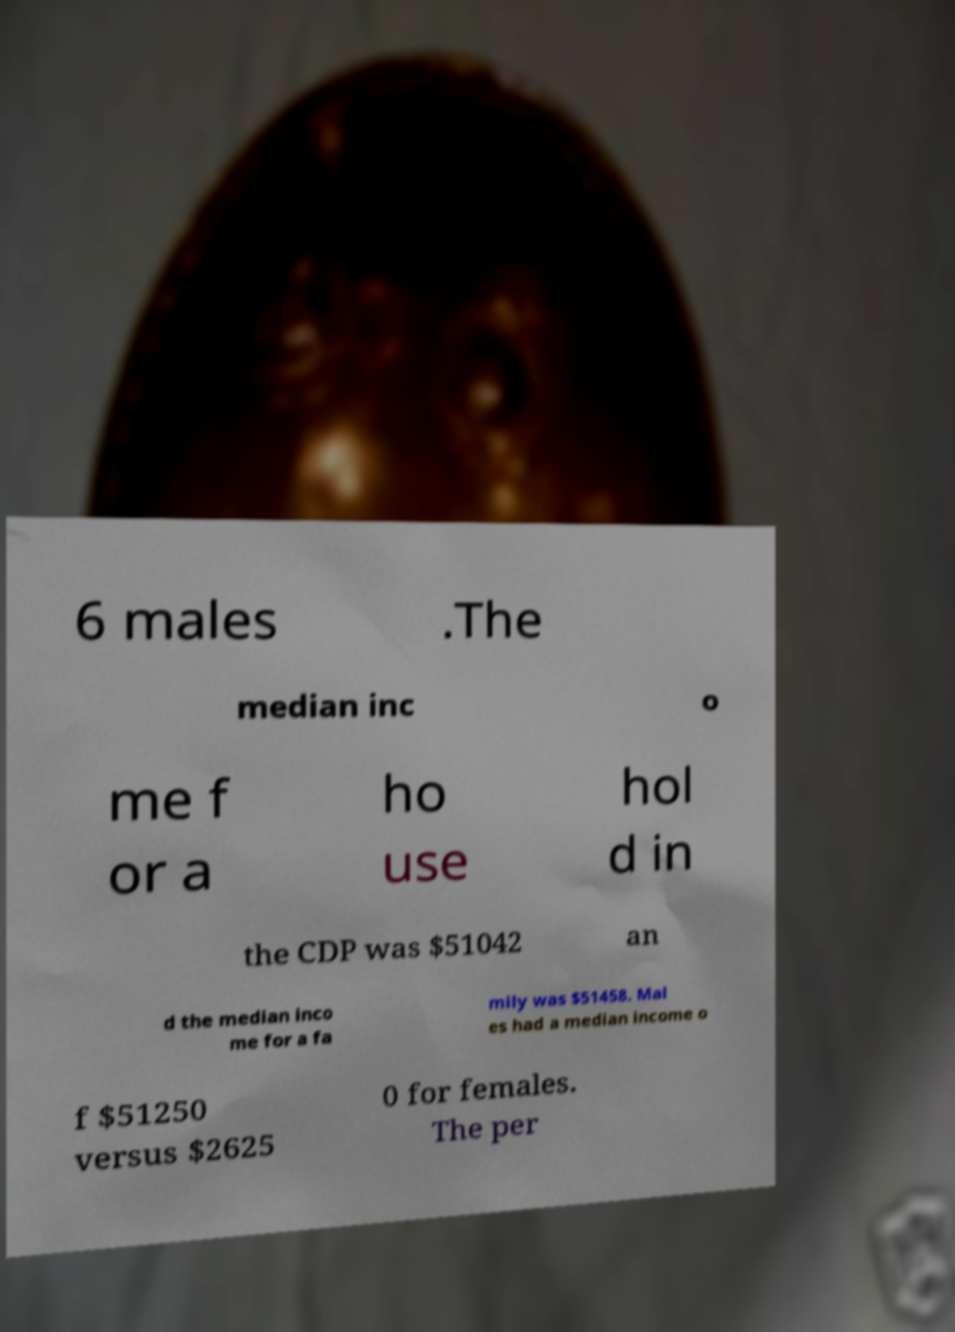For documentation purposes, I need the text within this image transcribed. Could you provide that? 6 males .The median inc o me f or a ho use hol d in the CDP was $51042 an d the median inco me for a fa mily was $51458. Mal es had a median income o f $51250 versus $2625 0 for females. The per 